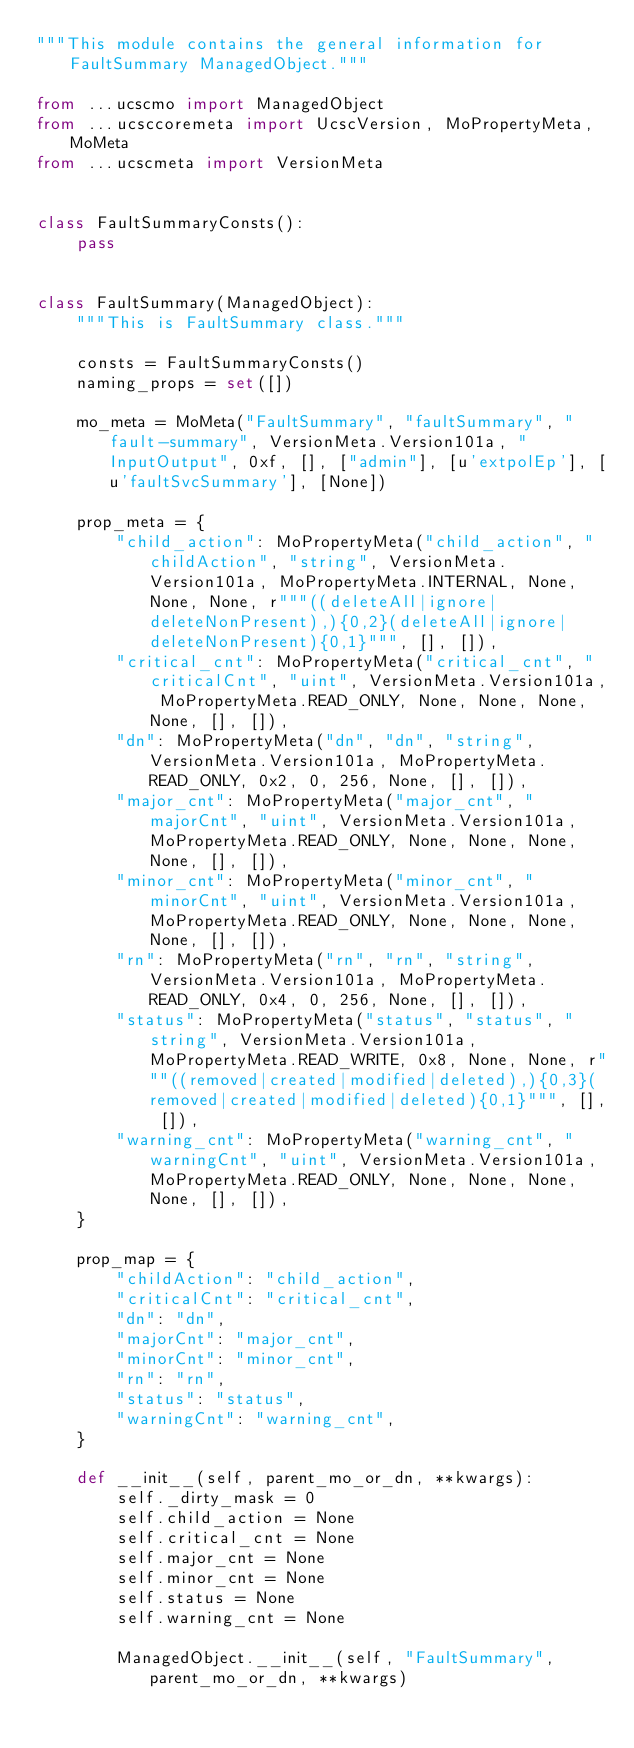Convert code to text. <code><loc_0><loc_0><loc_500><loc_500><_Python_>"""This module contains the general information for FaultSummary ManagedObject."""

from ...ucscmo import ManagedObject
from ...ucsccoremeta import UcscVersion, MoPropertyMeta, MoMeta
from ...ucscmeta import VersionMeta


class FaultSummaryConsts():
    pass


class FaultSummary(ManagedObject):
    """This is FaultSummary class."""

    consts = FaultSummaryConsts()
    naming_props = set([])

    mo_meta = MoMeta("FaultSummary", "faultSummary", "fault-summary", VersionMeta.Version101a, "InputOutput", 0xf, [], ["admin"], [u'extpolEp'], [u'faultSvcSummary'], [None])

    prop_meta = {
        "child_action": MoPropertyMeta("child_action", "childAction", "string", VersionMeta.Version101a, MoPropertyMeta.INTERNAL, None, None, None, r"""((deleteAll|ignore|deleteNonPresent),){0,2}(deleteAll|ignore|deleteNonPresent){0,1}""", [], []), 
        "critical_cnt": MoPropertyMeta("critical_cnt", "criticalCnt", "uint", VersionMeta.Version101a, MoPropertyMeta.READ_ONLY, None, None, None, None, [], []), 
        "dn": MoPropertyMeta("dn", "dn", "string", VersionMeta.Version101a, MoPropertyMeta.READ_ONLY, 0x2, 0, 256, None, [], []), 
        "major_cnt": MoPropertyMeta("major_cnt", "majorCnt", "uint", VersionMeta.Version101a, MoPropertyMeta.READ_ONLY, None, None, None, None, [], []), 
        "minor_cnt": MoPropertyMeta("minor_cnt", "minorCnt", "uint", VersionMeta.Version101a, MoPropertyMeta.READ_ONLY, None, None, None, None, [], []), 
        "rn": MoPropertyMeta("rn", "rn", "string", VersionMeta.Version101a, MoPropertyMeta.READ_ONLY, 0x4, 0, 256, None, [], []), 
        "status": MoPropertyMeta("status", "status", "string", VersionMeta.Version101a, MoPropertyMeta.READ_WRITE, 0x8, None, None, r"""((removed|created|modified|deleted),){0,3}(removed|created|modified|deleted){0,1}""", [], []), 
        "warning_cnt": MoPropertyMeta("warning_cnt", "warningCnt", "uint", VersionMeta.Version101a, MoPropertyMeta.READ_ONLY, None, None, None, None, [], []), 
    }

    prop_map = {
        "childAction": "child_action", 
        "criticalCnt": "critical_cnt", 
        "dn": "dn", 
        "majorCnt": "major_cnt", 
        "minorCnt": "minor_cnt", 
        "rn": "rn", 
        "status": "status", 
        "warningCnt": "warning_cnt", 
    }

    def __init__(self, parent_mo_or_dn, **kwargs):
        self._dirty_mask = 0
        self.child_action = None
        self.critical_cnt = None
        self.major_cnt = None
        self.minor_cnt = None
        self.status = None
        self.warning_cnt = None

        ManagedObject.__init__(self, "FaultSummary", parent_mo_or_dn, **kwargs)

</code> 